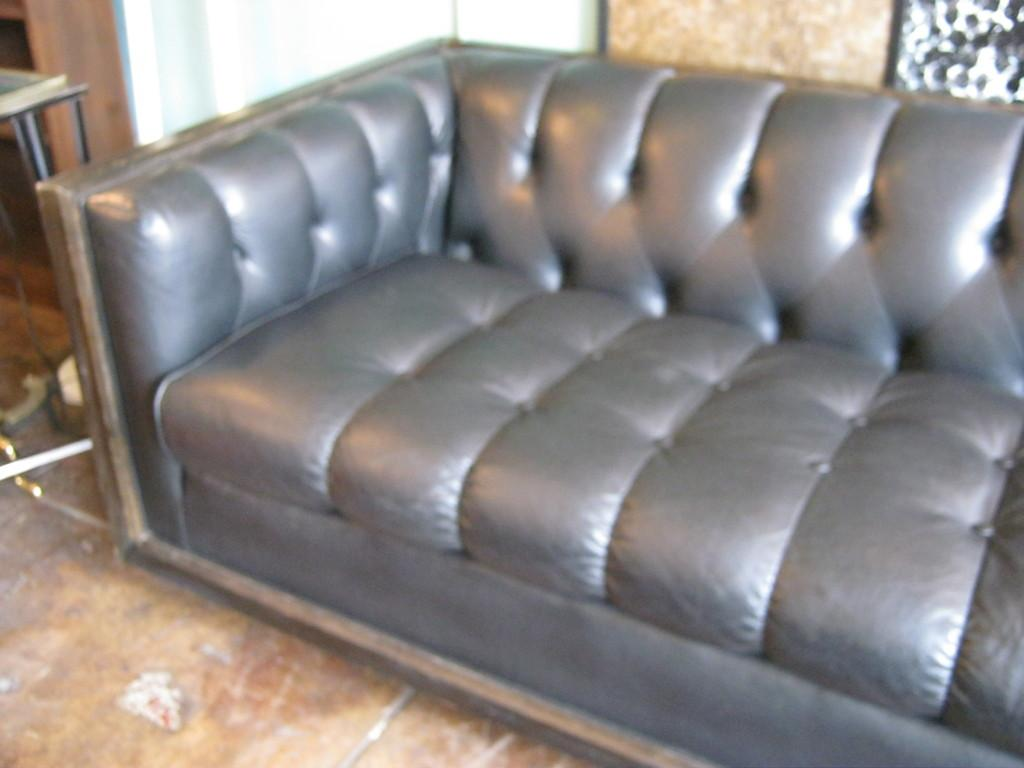What type of furniture is present in the image? There is a sofa and a table in the image. What can be seen in the background of the image? There is a wall in the background of the image. Is there any window treatment present in the image? Yes, there is a curtain associated with the wall in the background. How many kittens are sitting on the copper table in the image? There is no copper table or kittens present in the image. 